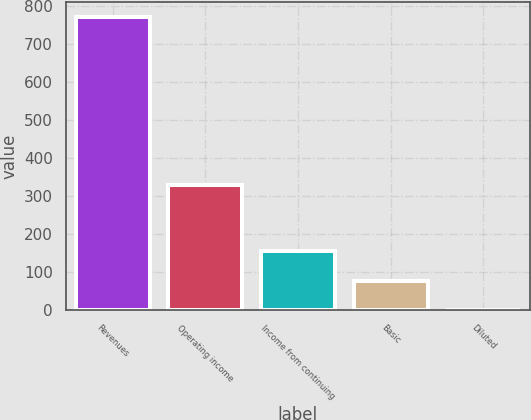Convert chart. <chart><loc_0><loc_0><loc_500><loc_500><bar_chart><fcel>Revenues<fcel>Operating income<fcel>Income from continuing<fcel>Basic<fcel>Diluted<nl><fcel>772<fcel>329<fcel>155.07<fcel>77.95<fcel>0.83<nl></chart> 